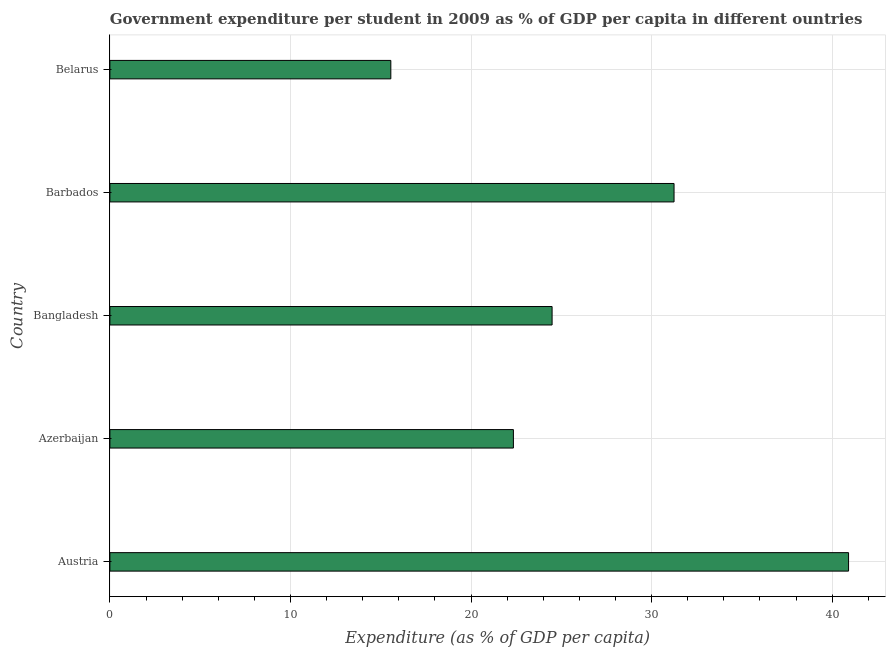What is the title of the graph?
Offer a terse response. Government expenditure per student in 2009 as % of GDP per capita in different ountries. What is the label or title of the X-axis?
Keep it short and to the point. Expenditure (as % of GDP per capita). What is the government expenditure per student in Austria?
Your answer should be very brief. 40.91. Across all countries, what is the maximum government expenditure per student?
Provide a short and direct response. 40.91. Across all countries, what is the minimum government expenditure per student?
Keep it short and to the point. 15.56. In which country was the government expenditure per student maximum?
Your answer should be compact. Austria. In which country was the government expenditure per student minimum?
Your response must be concise. Belarus. What is the sum of the government expenditure per student?
Provide a succinct answer. 134.54. What is the difference between the government expenditure per student in Azerbaijan and Belarus?
Offer a very short reply. 6.79. What is the average government expenditure per student per country?
Give a very brief answer. 26.91. What is the median government expenditure per student?
Ensure brevity in your answer.  24.49. What is the ratio of the government expenditure per student in Azerbaijan to that in Belarus?
Provide a succinct answer. 1.44. Is the government expenditure per student in Austria less than that in Bangladesh?
Your answer should be very brief. No. What is the difference between the highest and the second highest government expenditure per student?
Ensure brevity in your answer.  9.66. Is the sum of the government expenditure per student in Austria and Azerbaijan greater than the maximum government expenditure per student across all countries?
Provide a succinct answer. Yes. What is the difference between the highest and the lowest government expenditure per student?
Your response must be concise. 25.35. In how many countries, is the government expenditure per student greater than the average government expenditure per student taken over all countries?
Make the answer very short. 2. How many bars are there?
Your answer should be compact. 5. What is the Expenditure (as % of GDP per capita) of Austria?
Provide a succinct answer. 40.91. What is the Expenditure (as % of GDP per capita) in Azerbaijan?
Ensure brevity in your answer.  22.35. What is the Expenditure (as % of GDP per capita) in Bangladesh?
Make the answer very short. 24.49. What is the Expenditure (as % of GDP per capita) of Barbados?
Provide a succinct answer. 31.24. What is the Expenditure (as % of GDP per capita) of Belarus?
Keep it short and to the point. 15.56. What is the difference between the Expenditure (as % of GDP per capita) in Austria and Azerbaijan?
Ensure brevity in your answer.  18.56. What is the difference between the Expenditure (as % of GDP per capita) in Austria and Bangladesh?
Your response must be concise. 16.42. What is the difference between the Expenditure (as % of GDP per capita) in Austria and Barbados?
Provide a succinct answer. 9.66. What is the difference between the Expenditure (as % of GDP per capita) in Austria and Belarus?
Offer a terse response. 25.35. What is the difference between the Expenditure (as % of GDP per capita) in Azerbaijan and Bangladesh?
Keep it short and to the point. -2.14. What is the difference between the Expenditure (as % of GDP per capita) in Azerbaijan and Barbados?
Keep it short and to the point. -8.9. What is the difference between the Expenditure (as % of GDP per capita) in Azerbaijan and Belarus?
Keep it short and to the point. 6.79. What is the difference between the Expenditure (as % of GDP per capita) in Bangladesh and Barbados?
Your response must be concise. -6.75. What is the difference between the Expenditure (as % of GDP per capita) in Bangladesh and Belarus?
Offer a very short reply. 8.93. What is the difference between the Expenditure (as % of GDP per capita) in Barbados and Belarus?
Provide a succinct answer. 15.68. What is the ratio of the Expenditure (as % of GDP per capita) in Austria to that in Azerbaijan?
Your answer should be very brief. 1.83. What is the ratio of the Expenditure (as % of GDP per capita) in Austria to that in Bangladesh?
Give a very brief answer. 1.67. What is the ratio of the Expenditure (as % of GDP per capita) in Austria to that in Barbados?
Provide a succinct answer. 1.31. What is the ratio of the Expenditure (as % of GDP per capita) in Austria to that in Belarus?
Offer a very short reply. 2.63. What is the ratio of the Expenditure (as % of GDP per capita) in Azerbaijan to that in Bangladesh?
Offer a very short reply. 0.91. What is the ratio of the Expenditure (as % of GDP per capita) in Azerbaijan to that in Barbados?
Provide a succinct answer. 0.71. What is the ratio of the Expenditure (as % of GDP per capita) in Azerbaijan to that in Belarus?
Provide a succinct answer. 1.44. What is the ratio of the Expenditure (as % of GDP per capita) in Bangladesh to that in Barbados?
Your response must be concise. 0.78. What is the ratio of the Expenditure (as % of GDP per capita) in Bangladesh to that in Belarus?
Your response must be concise. 1.57. What is the ratio of the Expenditure (as % of GDP per capita) in Barbados to that in Belarus?
Keep it short and to the point. 2.01. 